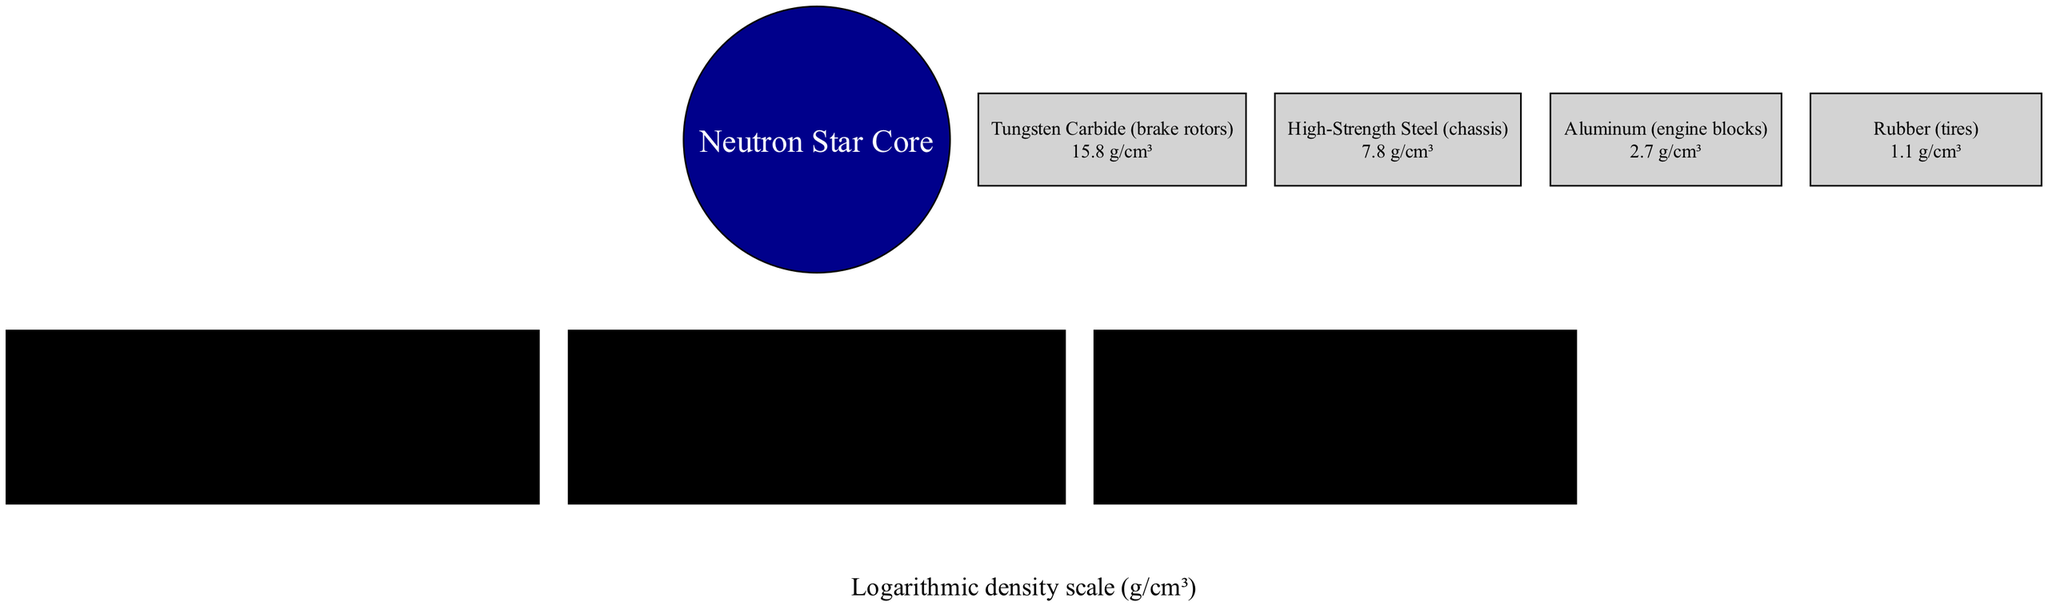What's the density of the Inner Core? The density of the Inner Core is clearly stated in the diagram as 1e15 g/cm³.
Answer: 1e15 g/cm³ What material is the Inner Core compared to? The comparison for the Inner Core is with tungsten carbide brake rotors, which is indicated in its accompanying text in the diagram.
Answer: Tungsten carbide brake rotors How many layers are displayed in the diagram? Counting the visible layers in the diagram, there are three layers: Inner Core, Outer Core, and Crust.
Answer: 3 What is the density of the Crust? The diagram specifies the density of the Crust as 1e11 g/cm³.
Answer: 1e11 g/cm³ How much denser is the Outer Core compared to high-strength steel chassis? The Outer Core is described as being 1 trillion times denser than high-strength steel chassis according to the information presented in the diagram.
Answer: 1 trillion times What is the total density of the neutron star compared to aluminum engine blocks? The Crust's density is 1 billion times denser than aluminum engine blocks, indicating that the layers above it are even denser, but specifically, the Crust provides this ratio.
Answer: 1 billion times Which material is the least dense shown in the comparisons? Among the materials listed in the comparisons, rubber has the lowest density of 1.1 g/cm³.
Answer: Rubber What is the density of high-strength steel chassis? The density for high-strength steel chassis is provided in the diagram as 7.8 g/cm³.
Answer: 7.8 g/cm³ What kind of scale is used for density in this diagram? The scale used for density measurement in this diagram is a logarithmic density scale, as mentioned at the bottom of the diagram.
Answer: Logarithmic density scale (g/cm³) 